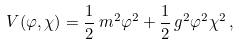<formula> <loc_0><loc_0><loc_500><loc_500>V ( \varphi , \chi ) = \frac { 1 } { 2 } \, m ^ { 2 } \varphi ^ { 2 } + \frac { 1 } { 2 } \, g ^ { 2 } \varphi ^ { 2 } \chi ^ { 2 } \, ,</formula> 